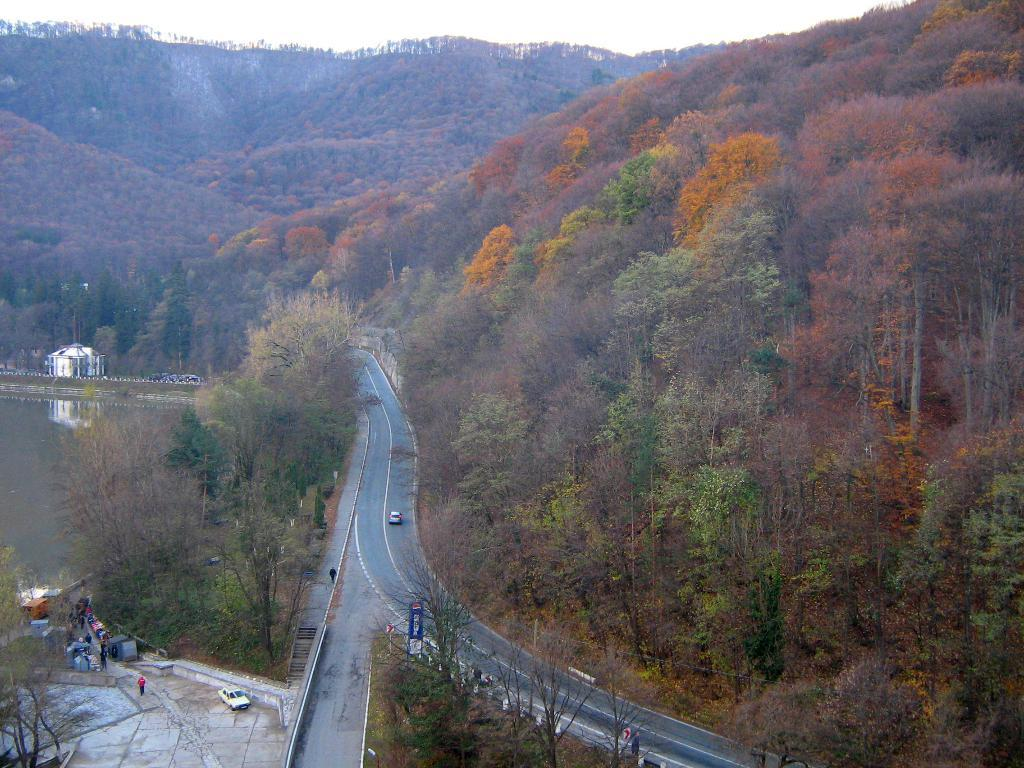What type of natural elements can be seen in the image? There are trees in the image. What type of man-made elements can be seen in the image? There are vehicles on the road and on the ground in the image. What can be seen on the left side of the image? Water, people, and vehicles can be seen on the left side of the image. What is visible in the background of the image? Hills and the sky are visible in the background of the image. Can you tell me how many people are smiling in the image? There is no information about people smiling in the image, as the facts provided do not mention any expressions or emotions. Is there a ring visible in the image? There is no mention of a ring in the provided facts, so it cannot be determined if a ring is present in the image. 